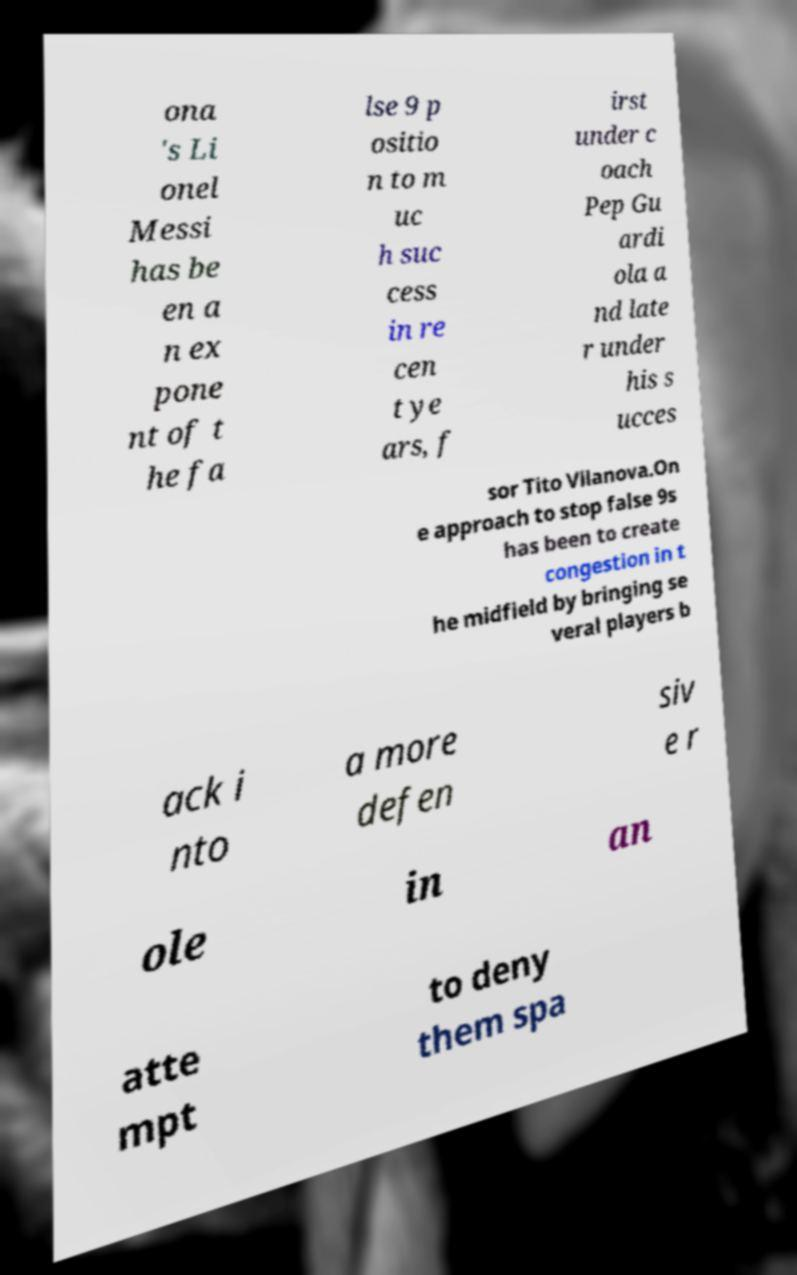Could you assist in decoding the text presented in this image and type it out clearly? The text in the image appears to be jumbled and partially obscured, making it difficult to read in full sequence. Based on visible parts, the text seems to discuss Lionel Messi's role as a 'false 9' in football and mentions tactics under coaches like Pep Guardiola and Tito Vilanova. The specific details such as tactics involving creating congestion in the midfield to counter players in the 'false 9' position are also noted. 